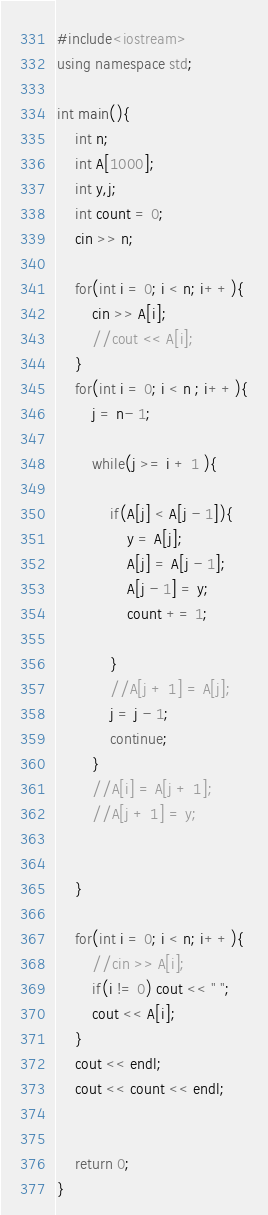Convert code to text. <code><loc_0><loc_0><loc_500><loc_500><_C++_>#include<iostream>
using namespace std;

int main(){
    int n;
    int A[1000];
    int y,j;
    int count = 0;
    cin >> n;
    
    for(int i = 0; i < n; i++){
        cin >> A[i];
        //cout << A[i];
    }
    for(int i = 0; i < n ; i++){
        j = n- 1;
        
        while(j >= i + 1 ){
            
            if(A[j] < A[j - 1]){
                y = A[j];
                A[j] = A[j - 1];
                A[j - 1] = y;
                count += 1;
                
            }
            //A[j + 1] = A[j];
            j = j - 1;
            continue;
        }
        //A[i] = A[j + 1];
        //A[j + 1] = y;
        
        
    }
    
    for(int i = 0; i < n; i++){
        //cin >> A[i];
        if(i != 0) cout << " ";
        cout << A[i];
    }
    cout << endl;
    cout << count << endl;
    
    
    return 0;
}

</code> 